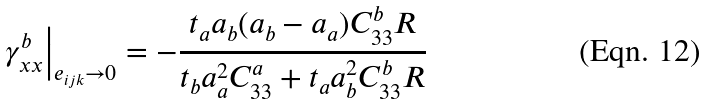Convert formula to latex. <formula><loc_0><loc_0><loc_500><loc_500>\left . \gamma _ { x x } ^ { b } \right | _ { e _ { i j k } \rightarrow 0 } = - \frac { t _ { a } a _ { b } ( a _ { b } - a _ { a } ) C _ { 3 3 } ^ { b } R } { t _ { b } a _ { a } ^ { 2 } C _ { 3 3 } ^ { a } + t _ { a } a _ { b } ^ { 2 } C _ { 3 3 } ^ { b } R }</formula> 